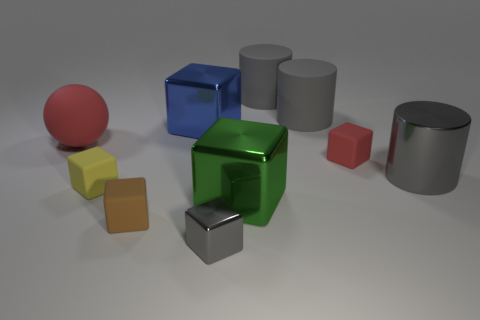Subtract all blue blocks. How many blocks are left? 5 Subtract all large blocks. How many blocks are left? 4 Subtract 2 blocks. How many blocks are left? 4 Subtract all blocks. How many objects are left? 4 Subtract all red blocks. Subtract all red cylinders. How many blocks are left? 5 Add 8 small gray things. How many small gray things exist? 9 Subtract 1 yellow cubes. How many objects are left? 9 Subtract all red matte blocks. Subtract all large red metallic spheres. How many objects are left? 9 Add 1 gray rubber objects. How many gray rubber objects are left? 3 